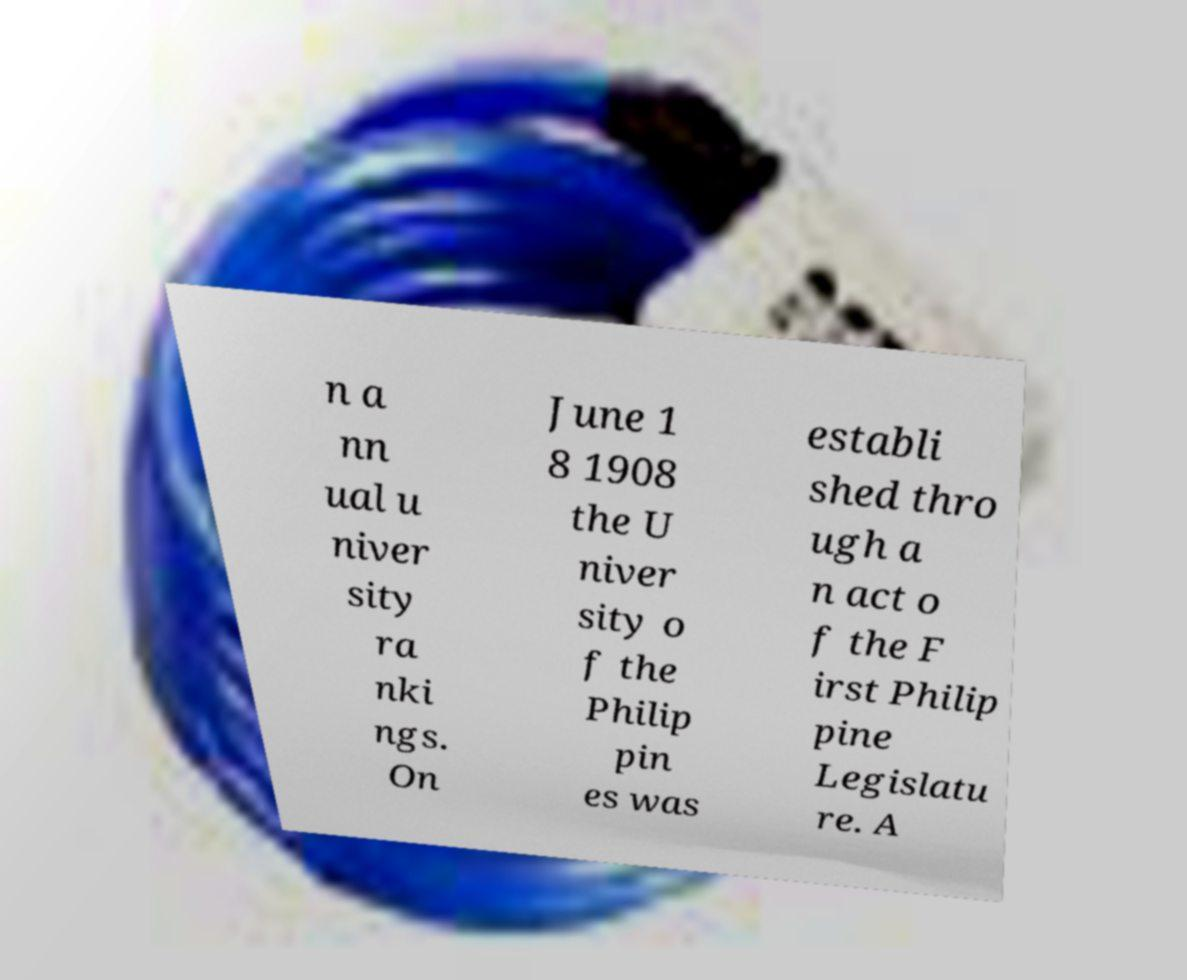Could you assist in decoding the text presented in this image and type it out clearly? n a nn ual u niver sity ra nki ngs. On June 1 8 1908 the U niver sity o f the Philip pin es was establi shed thro ugh a n act o f the F irst Philip pine Legislatu re. A 